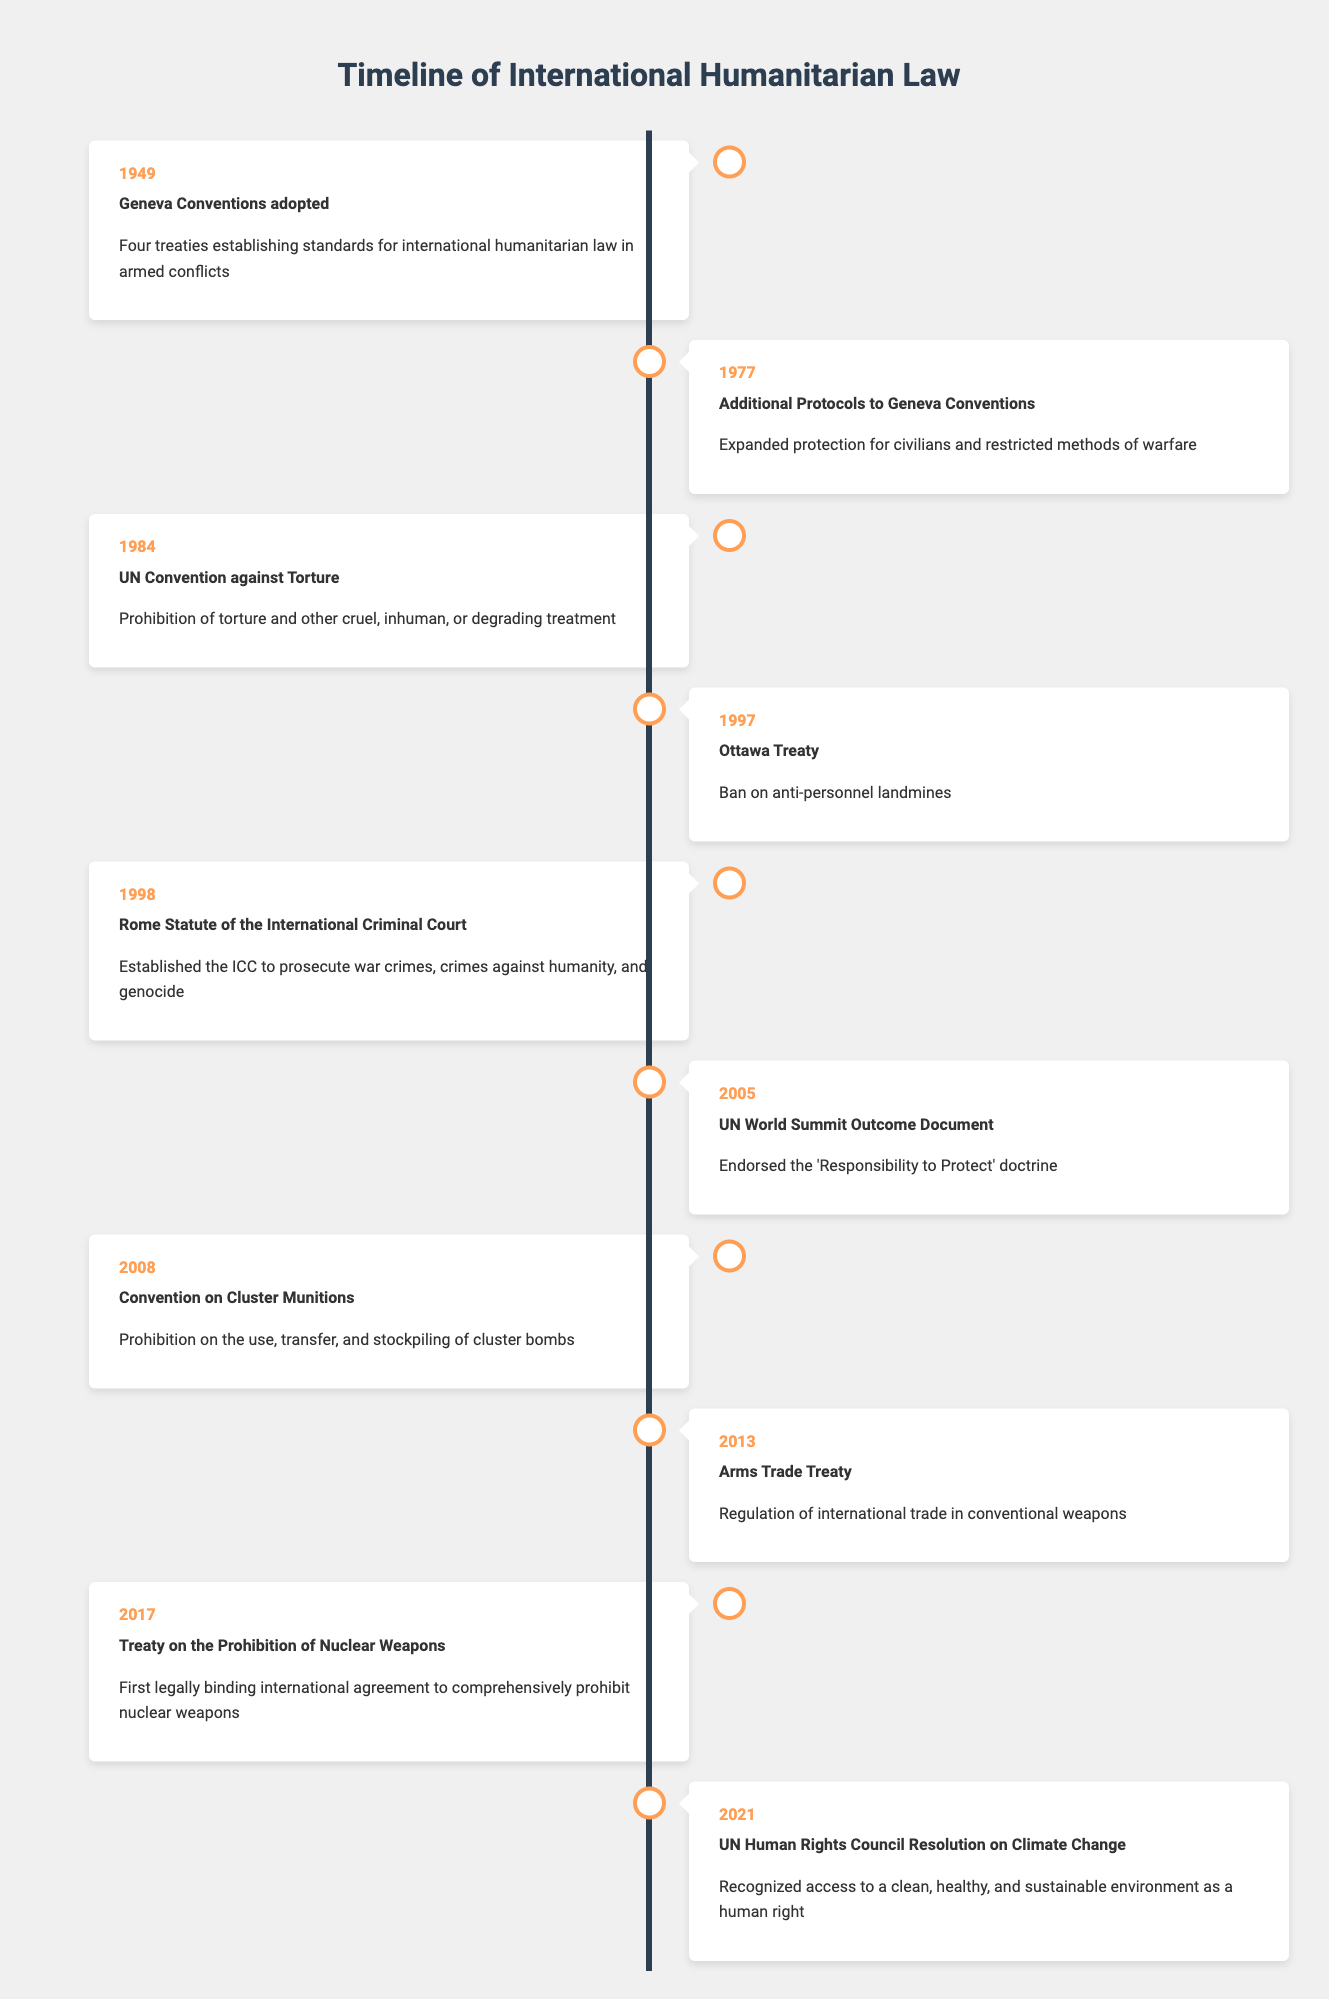What year were the Geneva Conventions adopted? According to the table, the Geneva Conventions were adopted in 1949, as indicated in the first row of the timeline.
Answer: 1949 Which event occurred in 1998? The row for the year 1998 lists the event as the Rome Statute of the International Criminal Court. This information can be found directly in the table.
Answer: Rome Statute of the International Criminal Court How many treaties or conventions were adopted before 2000? By examining the timeline table, we can count the events from 1949 to 1998. There are a total of 5 significant events before the year 2000.
Answer: 5 Did the Ottawa Treaty aim to ban any type of weapon? The table describes the Ottawa Treaty as a ban on anti-personnel landmines, indicating that it does indeed focus on banning a specific type of weapon.
Answer: Yes List the events that expanded protections for civilians. The table shows the 1977 Additional Protocols to the Geneva Conventions as the event that expanded protections for civilians. Further, the UN Convention against Torture in 1984 also aims to protect individuals from inhumane treatment. Thus, these two events focus on expanding protections for civilians.
Answer: Additional Protocols to Geneva Conventions, UN Convention against Torture What is the difference in years between the adoption of the Ottawa Treaty and the Arms Trade Treaty? The Ottawa Treaty was adopted in 1997 and the Arms Trade Treaty in 2013. Calculating the difference, 2013 - 1997 equals 16 years.
Answer: 16 years Is there a document endorsing the 'Responsibility to Protect' doctrine? Yes, the table states that the UN World Summit Outcome Document in 2005 endorsed the ‘Responsibility to Protect’ doctrine, confirming the existence of such a document.
Answer: Yes What was the significance of the Treaty on the Prohibition of Nuclear Weapons in 2017? According to the table, this treaty is significant as it is the first legally binding international agreement to comprehensively prohibit nuclear weapons, representing a major step in disarmament efforts.
Answer: First legally binding international agreement to prohibit nuclear weapons How many events took place in the 21st century? Reviewing the table entries from the year 2000 onward, we find four events: the UN World Summit Outcome Document (2005), Convention on Cluster Munitions (2008), Arms Trade Treaty (2013), and the Treaty on the Prohibition of Nuclear Weapons (2017). Thus, there are four events in the 21st century.
Answer: 4 